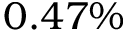<formula> <loc_0><loc_0><loc_500><loc_500>0 . 4 7 \%</formula> 